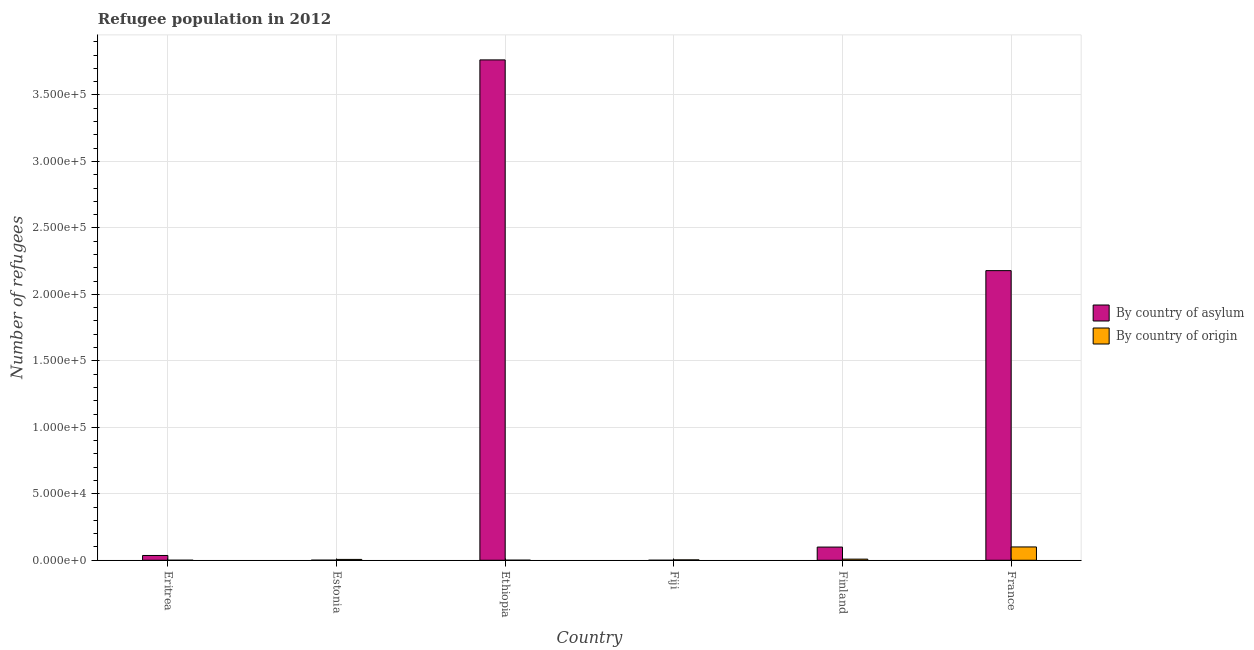How many different coloured bars are there?
Offer a terse response. 2. How many groups of bars are there?
Your answer should be very brief. 6. Are the number of bars per tick equal to the number of legend labels?
Keep it short and to the point. Yes. What is the number of refugees by country of asylum in Estonia?
Provide a succinct answer. 63. Across all countries, what is the maximum number of refugees by country of origin?
Offer a terse response. 1.00e+04. Across all countries, what is the minimum number of refugees by country of origin?
Offer a terse response. 9. In which country was the number of refugees by country of asylum maximum?
Make the answer very short. Ethiopia. In which country was the number of refugees by country of asylum minimum?
Your response must be concise. Fiji. What is the total number of refugees by country of origin in the graph?
Offer a terse response. 1.19e+04. What is the difference between the number of refugees by country of origin in Eritrea and that in France?
Keep it short and to the point. -1.00e+04. What is the difference between the number of refugees by country of origin in Estonia and the number of refugees by country of asylum in Eritrea?
Offer a very short reply. -2960. What is the average number of refugees by country of origin per country?
Your response must be concise. 1976. What is the difference between the number of refugees by country of origin and number of refugees by country of asylum in Finland?
Make the answer very short. -9075. In how many countries, is the number of refugees by country of asylum greater than 190000 ?
Provide a succinct answer. 2. What is the ratio of the number of refugees by country of asylum in Estonia to that in Finland?
Offer a very short reply. 0.01. Is the number of refugees by country of asylum in Eritrea less than that in Ethiopia?
Offer a terse response. Yes. Is the difference between the number of refugees by country of origin in Estonia and Finland greater than the difference between the number of refugees by country of asylum in Estonia and Finland?
Give a very brief answer. Yes. What is the difference between the highest and the second highest number of refugees by country of asylum?
Your response must be concise. 1.59e+05. What is the difference between the highest and the lowest number of refugees by country of asylum?
Your response must be concise. 3.76e+05. In how many countries, is the number of refugees by country of origin greater than the average number of refugees by country of origin taken over all countries?
Keep it short and to the point. 1. What does the 1st bar from the left in Fiji represents?
Give a very brief answer. By country of asylum. What does the 2nd bar from the right in Estonia represents?
Give a very brief answer. By country of asylum. How many bars are there?
Your answer should be very brief. 12. Are all the bars in the graph horizontal?
Offer a very short reply. No. Does the graph contain any zero values?
Your answer should be very brief. No. Where does the legend appear in the graph?
Keep it short and to the point. Center right. How are the legend labels stacked?
Your answer should be compact. Vertical. What is the title of the graph?
Offer a terse response. Refugee population in 2012. What is the label or title of the Y-axis?
Offer a very short reply. Number of refugees. What is the Number of refugees in By country of asylum in Eritrea?
Ensure brevity in your answer.  3600. What is the Number of refugees in By country of origin in Eritrea?
Give a very brief answer. 9. What is the Number of refugees in By country of asylum in Estonia?
Give a very brief answer. 63. What is the Number of refugees in By country of origin in Estonia?
Your answer should be compact. 640. What is the Number of refugees of By country of asylum in Ethiopia?
Offer a terse response. 3.76e+05. What is the Number of refugees of By country of origin in Ethiopia?
Give a very brief answer. 54. What is the Number of refugees in By country of origin in Fiji?
Your answer should be compact. 289. What is the Number of refugees of By country of asylum in Finland?
Your answer should be very brief. 9919. What is the Number of refugees of By country of origin in Finland?
Keep it short and to the point. 844. What is the Number of refugees of By country of asylum in France?
Make the answer very short. 2.18e+05. What is the Number of refugees in By country of origin in France?
Your answer should be compact. 1.00e+04. Across all countries, what is the maximum Number of refugees in By country of asylum?
Provide a short and direct response. 3.76e+05. Across all countries, what is the maximum Number of refugees of By country of origin?
Give a very brief answer. 1.00e+04. Across all countries, what is the minimum Number of refugees in By country of asylum?
Your answer should be very brief. 6. Across all countries, what is the minimum Number of refugees in By country of origin?
Offer a very short reply. 9. What is the total Number of refugees in By country of asylum in the graph?
Your answer should be compact. 6.08e+05. What is the total Number of refugees in By country of origin in the graph?
Your answer should be compact. 1.19e+04. What is the difference between the Number of refugees in By country of asylum in Eritrea and that in Estonia?
Offer a very short reply. 3537. What is the difference between the Number of refugees of By country of origin in Eritrea and that in Estonia?
Your response must be concise. -631. What is the difference between the Number of refugees of By country of asylum in Eritrea and that in Ethiopia?
Your answer should be very brief. -3.73e+05. What is the difference between the Number of refugees of By country of origin in Eritrea and that in Ethiopia?
Provide a succinct answer. -45. What is the difference between the Number of refugees of By country of asylum in Eritrea and that in Fiji?
Keep it short and to the point. 3594. What is the difference between the Number of refugees in By country of origin in Eritrea and that in Fiji?
Keep it short and to the point. -280. What is the difference between the Number of refugees of By country of asylum in Eritrea and that in Finland?
Your response must be concise. -6319. What is the difference between the Number of refugees of By country of origin in Eritrea and that in Finland?
Keep it short and to the point. -835. What is the difference between the Number of refugees in By country of asylum in Eritrea and that in France?
Your response must be concise. -2.14e+05. What is the difference between the Number of refugees of By country of origin in Eritrea and that in France?
Give a very brief answer. -1.00e+04. What is the difference between the Number of refugees of By country of asylum in Estonia and that in Ethiopia?
Ensure brevity in your answer.  -3.76e+05. What is the difference between the Number of refugees of By country of origin in Estonia and that in Ethiopia?
Make the answer very short. 586. What is the difference between the Number of refugees in By country of asylum in Estonia and that in Fiji?
Give a very brief answer. 57. What is the difference between the Number of refugees in By country of origin in Estonia and that in Fiji?
Provide a short and direct response. 351. What is the difference between the Number of refugees of By country of asylum in Estonia and that in Finland?
Offer a very short reply. -9856. What is the difference between the Number of refugees in By country of origin in Estonia and that in Finland?
Your response must be concise. -204. What is the difference between the Number of refugees of By country of asylum in Estonia and that in France?
Offer a terse response. -2.18e+05. What is the difference between the Number of refugees of By country of origin in Estonia and that in France?
Offer a very short reply. -9380. What is the difference between the Number of refugees of By country of asylum in Ethiopia and that in Fiji?
Your answer should be very brief. 3.76e+05. What is the difference between the Number of refugees of By country of origin in Ethiopia and that in Fiji?
Make the answer very short. -235. What is the difference between the Number of refugees in By country of asylum in Ethiopia and that in Finland?
Your answer should be very brief. 3.66e+05. What is the difference between the Number of refugees of By country of origin in Ethiopia and that in Finland?
Give a very brief answer. -790. What is the difference between the Number of refugees of By country of asylum in Ethiopia and that in France?
Offer a very short reply. 1.59e+05. What is the difference between the Number of refugees in By country of origin in Ethiopia and that in France?
Your answer should be very brief. -9966. What is the difference between the Number of refugees of By country of asylum in Fiji and that in Finland?
Your answer should be very brief. -9913. What is the difference between the Number of refugees of By country of origin in Fiji and that in Finland?
Offer a terse response. -555. What is the difference between the Number of refugees in By country of asylum in Fiji and that in France?
Your answer should be compact. -2.18e+05. What is the difference between the Number of refugees in By country of origin in Fiji and that in France?
Offer a very short reply. -9731. What is the difference between the Number of refugees of By country of asylum in Finland and that in France?
Your answer should be very brief. -2.08e+05. What is the difference between the Number of refugees of By country of origin in Finland and that in France?
Give a very brief answer. -9176. What is the difference between the Number of refugees of By country of asylum in Eritrea and the Number of refugees of By country of origin in Estonia?
Keep it short and to the point. 2960. What is the difference between the Number of refugees in By country of asylum in Eritrea and the Number of refugees in By country of origin in Ethiopia?
Your response must be concise. 3546. What is the difference between the Number of refugees of By country of asylum in Eritrea and the Number of refugees of By country of origin in Fiji?
Offer a terse response. 3311. What is the difference between the Number of refugees in By country of asylum in Eritrea and the Number of refugees in By country of origin in Finland?
Offer a very short reply. 2756. What is the difference between the Number of refugees in By country of asylum in Eritrea and the Number of refugees in By country of origin in France?
Give a very brief answer. -6420. What is the difference between the Number of refugees in By country of asylum in Estonia and the Number of refugees in By country of origin in Ethiopia?
Provide a succinct answer. 9. What is the difference between the Number of refugees of By country of asylum in Estonia and the Number of refugees of By country of origin in Fiji?
Your answer should be compact. -226. What is the difference between the Number of refugees in By country of asylum in Estonia and the Number of refugees in By country of origin in Finland?
Make the answer very short. -781. What is the difference between the Number of refugees in By country of asylum in Estonia and the Number of refugees in By country of origin in France?
Your answer should be compact. -9957. What is the difference between the Number of refugees in By country of asylum in Ethiopia and the Number of refugees in By country of origin in Fiji?
Ensure brevity in your answer.  3.76e+05. What is the difference between the Number of refugees in By country of asylum in Ethiopia and the Number of refugees in By country of origin in Finland?
Your response must be concise. 3.76e+05. What is the difference between the Number of refugees of By country of asylum in Ethiopia and the Number of refugees of By country of origin in France?
Give a very brief answer. 3.66e+05. What is the difference between the Number of refugees in By country of asylum in Fiji and the Number of refugees in By country of origin in Finland?
Provide a short and direct response. -838. What is the difference between the Number of refugees of By country of asylum in Fiji and the Number of refugees of By country of origin in France?
Your response must be concise. -1.00e+04. What is the difference between the Number of refugees of By country of asylum in Finland and the Number of refugees of By country of origin in France?
Keep it short and to the point. -101. What is the average Number of refugees in By country of asylum per country?
Your answer should be very brief. 1.01e+05. What is the average Number of refugees of By country of origin per country?
Provide a short and direct response. 1976. What is the difference between the Number of refugees in By country of asylum and Number of refugees in By country of origin in Eritrea?
Provide a short and direct response. 3591. What is the difference between the Number of refugees in By country of asylum and Number of refugees in By country of origin in Estonia?
Your answer should be compact. -577. What is the difference between the Number of refugees in By country of asylum and Number of refugees in By country of origin in Ethiopia?
Provide a short and direct response. 3.76e+05. What is the difference between the Number of refugees in By country of asylum and Number of refugees in By country of origin in Fiji?
Offer a terse response. -283. What is the difference between the Number of refugees of By country of asylum and Number of refugees of By country of origin in Finland?
Your response must be concise. 9075. What is the difference between the Number of refugees in By country of asylum and Number of refugees in By country of origin in France?
Provide a short and direct response. 2.08e+05. What is the ratio of the Number of refugees of By country of asylum in Eritrea to that in Estonia?
Give a very brief answer. 57.14. What is the ratio of the Number of refugees of By country of origin in Eritrea to that in Estonia?
Offer a very short reply. 0.01. What is the ratio of the Number of refugees in By country of asylum in Eritrea to that in Ethiopia?
Keep it short and to the point. 0.01. What is the ratio of the Number of refugees of By country of asylum in Eritrea to that in Fiji?
Your answer should be very brief. 600. What is the ratio of the Number of refugees in By country of origin in Eritrea to that in Fiji?
Your answer should be very brief. 0.03. What is the ratio of the Number of refugees of By country of asylum in Eritrea to that in Finland?
Keep it short and to the point. 0.36. What is the ratio of the Number of refugees of By country of origin in Eritrea to that in Finland?
Ensure brevity in your answer.  0.01. What is the ratio of the Number of refugees of By country of asylum in Eritrea to that in France?
Your response must be concise. 0.02. What is the ratio of the Number of refugees in By country of origin in Eritrea to that in France?
Provide a short and direct response. 0. What is the ratio of the Number of refugees in By country of asylum in Estonia to that in Ethiopia?
Give a very brief answer. 0. What is the ratio of the Number of refugees of By country of origin in Estonia to that in Ethiopia?
Keep it short and to the point. 11.85. What is the ratio of the Number of refugees in By country of origin in Estonia to that in Fiji?
Provide a short and direct response. 2.21. What is the ratio of the Number of refugees in By country of asylum in Estonia to that in Finland?
Keep it short and to the point. 0.01. What is the ratio of the Number of refugees in By country of origin in Estonia to that in Finland?
Offer a very short reply. 0.76. What is the ratio of the Number of refugees of By country of asylum in Estonia to that in France?
Offer a very short reply. 0. What is the ratio of the Number of refugees of By country of origin in Estonia to that in France?
Offer a terse response. 0.06. What is the ratio of the Number of refugees in By country of asylum in Ethiopia to that in Fiji?
Provide a short and direct response. 6.27e+04. What is the ratio of the Number of refugees in By country of origin in Ethiopia to that in Fiji?
Give a very brief answer. 0.19. What is the ratio of the Number of refugees of By country of asylum in Ethiopia to that in Finland?
Provide a short and direct response. 37.95. What is the ratio of the Number of refugees of By country of origin in Ethiopia to that in Finland?
Offer a terse response. 0.06. What is the ratio of the Number of refugees of By country of asylum in Ethiopia to that in France?
Ensure brevity in your answer.  1.73. What is the ratio of the Number of refugees in By country of origin in Ethiopia to that in France?
Provide a short and direct response. 0.01. What is the ratio of the Number of refugees in By country of asylum in Fiji to that in Finland?
Keep it short and to the point. 0. What is the ratio of the Number of refugees of By country of origin in Fiji to that in Finland?
Give a very brief answer. 0.34. What is the ratio of the Number of refugees of By country of asylum in Fiji to that in France?
Make the answer very short. 0. What is the ratio of the Number of refugees in By country of origin in Fiji to that in France?
Your answer should be very brief. 0.03. What is the ratio of the Number of refugees of By country of asylum in Finland to that in France?
Offer a terse response. 0.05. What is the ratio of the Number of refugees in By country of origin in Finland to that in France?
Provide a succinct answer. 0.08. What is the difference between the highest and the second highest Number of refugees of By country of asylum?
Provide a succinct answer. 1.59e+05. What is the difference between the highest and the second highest Number of refugees in By country of origin?
Provide a succinct answer. 9176. What is the difference between the highest and the lowest Number of refugees of By country of asylum?
Your answer should be compact. 3.76e+05. What is the difference between the highest and the lowest Number of refugees in By country of origin?
Your response must be concise. 1.00e+04. 